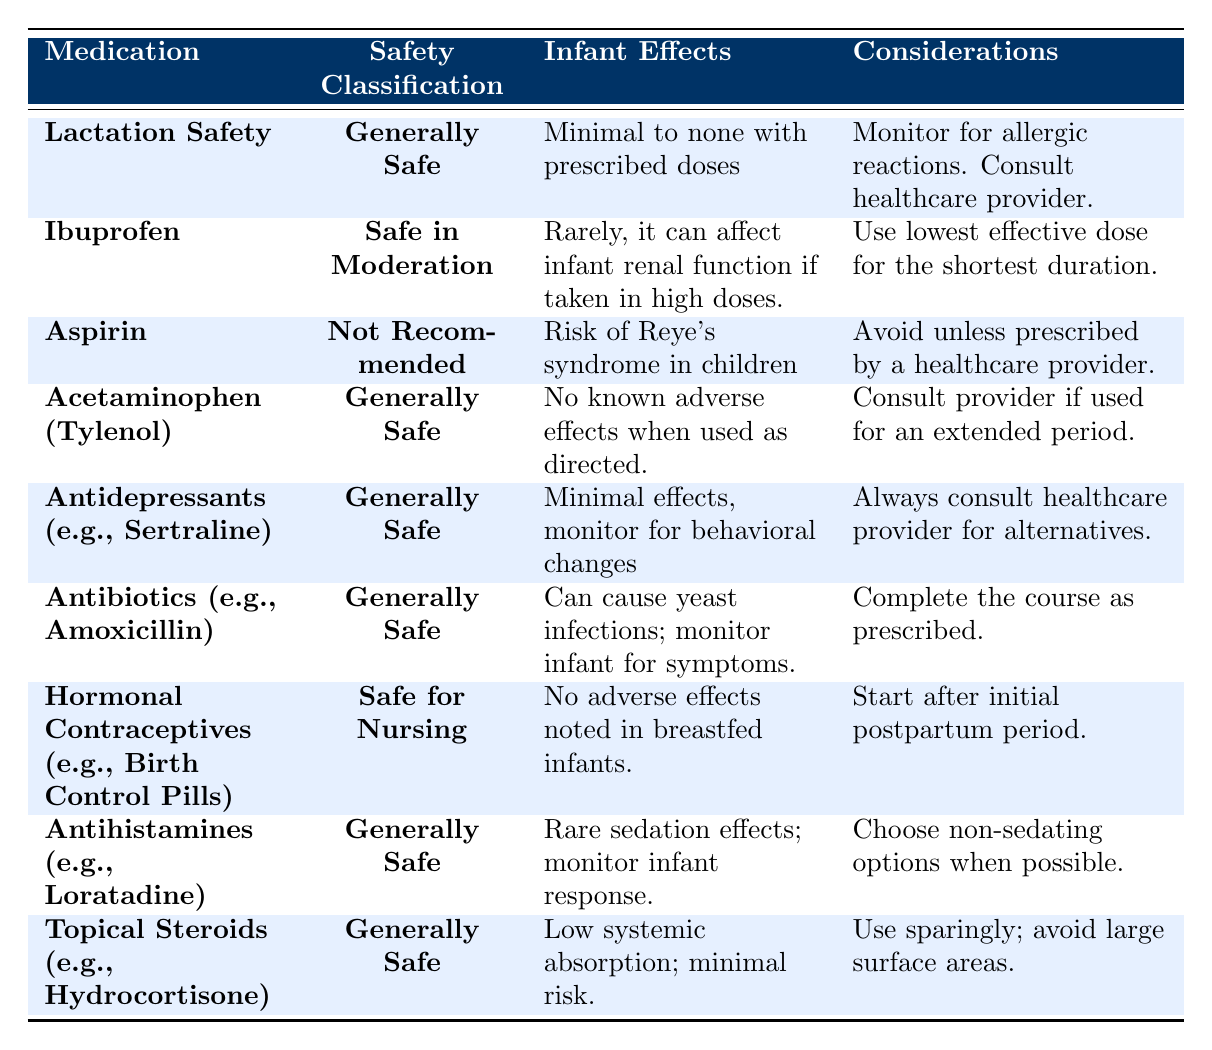What is the safety classification of Ibuprofen? The table lists "Ibuprofen" under the "Safety Classification" column, which states it is "**Safe in Moderation**".
Answer: Safe in Moderation Which medication is not recommended for new mothers? By looking at the table, "Aspirin" is noted under the safety classification as "**Not Recommended**".
Answer: Aspirin Does Acetaminophen (Tylenol) have any known adverse effects on infants? The table states that "Acetaminophen (Tylenol)" has "No known adverse effects when used as directed", indicating it is generally safe.
Answer: No What considerations should be taken when using Antibiotics like Amoxicillin? The table specifies that "Antibiotics (e.g., Amoxicillin)" should be "Complete the course as prescribed."
Answer: Complete the course as prescribed If a mother is prescribed an antidepressant, what should she do regarding the medication? The table indicates that for antidepressants, a mother should "Always consult a healthcare provider for alternatives."
Answer: Consult a healthcare provider for alternatives Is it safe to use hormonal contraceptives while nursing? The table specifies that "Hormonal Contraceptives (e.g., Birth Control Pills)" have a classification of "**Safe for Nursing**", thus confirming their safety.
Answer: Yes Which medications require monitoring for allergic reactions? The only medication in the table that specifically mentions monitoring for allergic reactions is "**Lactation Safety**".
Answer: Lactation Safety How many medications are classified as Generally Safe? Upon inspecting the table, it can be deduced that there are four medications listed as "Generally Safe": Lactation Safety, Acetaminophen (Tylenol), Antidepressants (e.g., Sertraline), Antibiotics (e.g., Amoxicillin), Antihistamines (e.g., Loratadine), and Topical Steroids (e.g., Hydrocortisone), totaling six in all.
Answer: Six What should a new mother do if experiencing behavioral changes while taking Sertraline? According to the table, it is recommended to "monitor for behavioral changes," stressing the importance of consulting a healthcare provider.
Answer: Monitor and consult a healthcare provider Are there noted effects of Antihistamines like Loratadine on infants? The table mentions that Antihistamines can have "rare sedation effects; monitor infant response," so there can be effects to observe.
Answer: Yes, rare sedation effects 